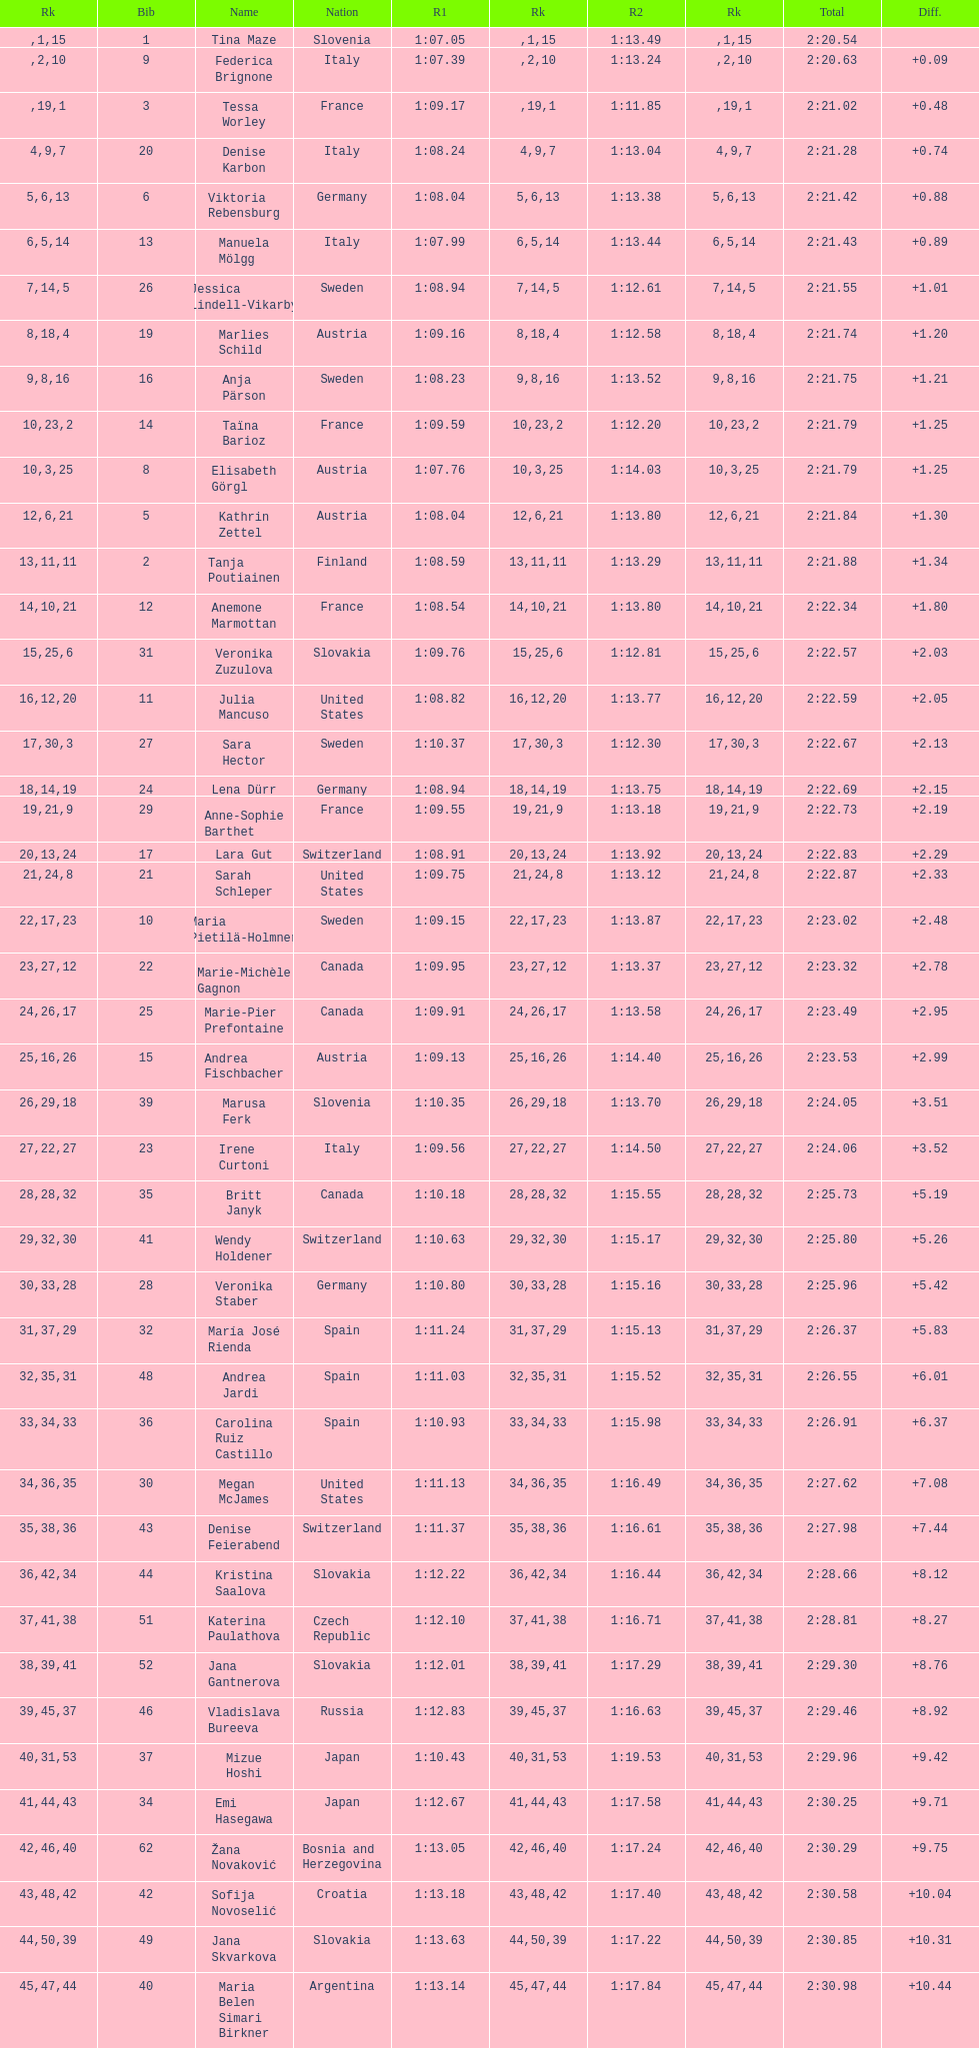How many total names are there? 116. 